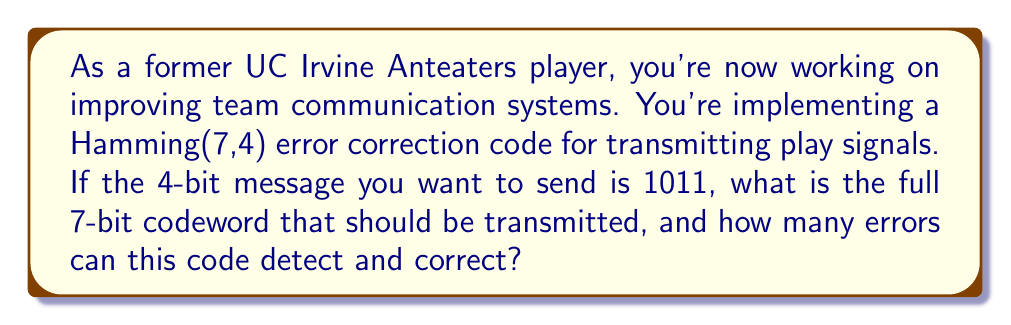Solve this math problem. Let's approach this step-by-step:

1) The Hamming(7,4) code uses 7 bits to encode 4 data bits, with 3 parity bits.

2) The bit positions are numbered from 1 to 7, with positions 1, 2, and 4 reserved for parity bits.

3) The data bits (1011) will be placed in positions 3, 5, 6, and 7.

4) The codeword structure will be:
   $$p_1 p_2 d_1 p_3 d_2 d_3 d_4$$

5) To determine the parity bits:
   
   $p_1$: checks bits 1,3,5,7
   $p_2$: checks bits 2,3,6,7
   $p_4$: checks bits 4,5,6,7

6) Calculate each parity bit:
   
   $p_1$: $1 \oplus d_1 \oplus d_2 \oplus d_4 = 1 \oplus 1 \oplus 0 \oplus 1 = 1$
   $p_2$: $1 \oplus d_1 \oplus d_3 \oplus d_4 = 1 \oplus 1 \oplus 1 \oplus 1 = 0$
   $p_4$: $1 \oplus d_2 \oplus d_3 \oplus d_4 = 1 \oplus 0 \oplus 1 \oplus 1 = 1$

7) The final codeword is: 1011011

8) Hamming(7,4) can detect up to 2 errors and correct 1 error.

   - It can detect 2 errors because any 2 errors will result in a syndrome that doesn't correspond to any valid codeword.
   - It can correct 1 error because each possible single-bit error produces a unique syndrome, allowing the error to be located and corrected.
Answer: The 7-bit codeword to be transmitted is 1011011. The Hamming(7,4) code can detect up to 2 errors and correct 1 error. 